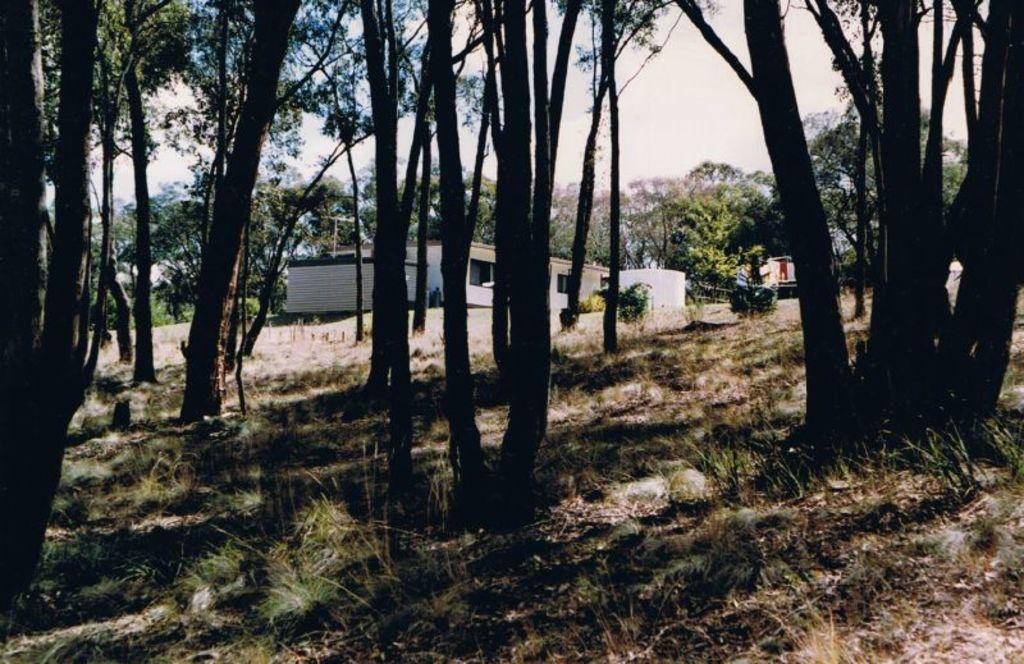How would you summarize this image in a sentence or two? In the image in the center, we can see the sky, clouds, trees, buildings, windows, plants and grass. 